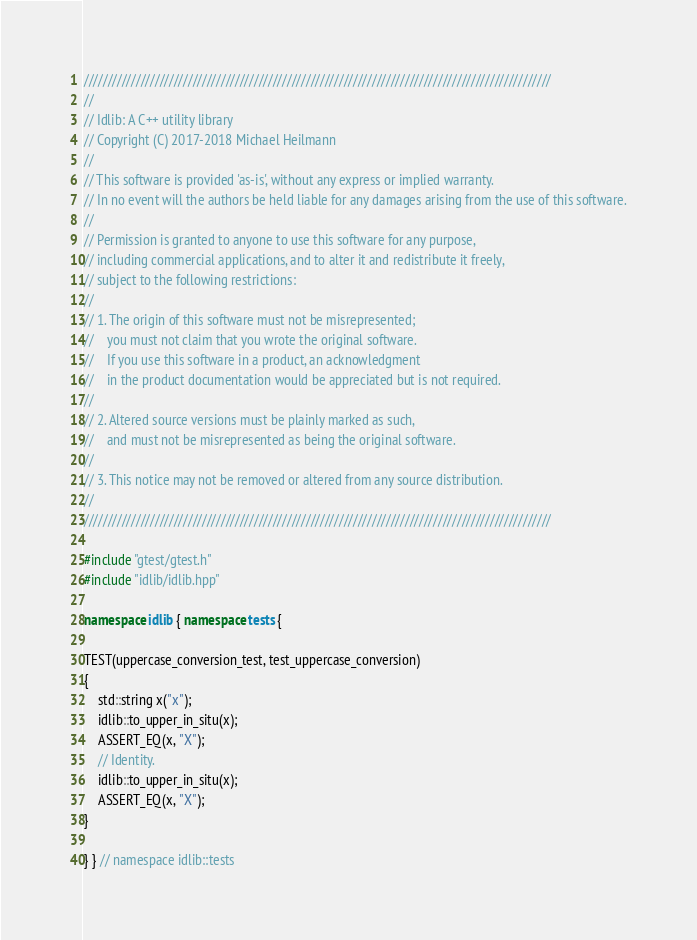Convert code to text. <code><loc_0><loc_0><loc_500><loc_500><_C++_>///////////////////////////////////////////////////////////////////////////////////////////////////
//
// Idlib: A C++ utility library
// Copyright (C) 2017-2018 Michael Heilmann
//
// This software is provided 'as-is', without any express or implied warranty.
// In no event will the authors be held liable for any damages arising from the use of this software.
//
// Permission is granted to anyone to use this software for any purpose,
// including commercial applications, and to alter it and redistribute it freely,
// subject to the following restrictions:
//
// 1. The origin of this software must not be misrepresented;
//    you must not claim that you wrote the original software.
//    If you use this software in a product, an acknowledgment
//    in the product documentation would be appreciated but is not required.
//
// 2. Altered source versions must be plainly marked as such,
//    and must not be misrepresented as being the original software.
//
// 3. This notice may not be removed or altered from any source distribution.
//
///////////////////////////////////////////////////////////////////////////////////////////////////

#include "gtest/gtest.h"
#include "idlib/idlib.hpp"

namespace idlib { namespace tests {

TEST(uppercase_conversion_test, test_uppercase_conversion)
{
    std::string x("x");
    idlib::to_upper_in_situ(x);
    ASSERT_EQ(x, "X");
    // Identity.
    idlib::to_upper_in_situ(x);
    ASSERT_EQ(x, "X");
}

} } // namespace idlib::tests
</code> 